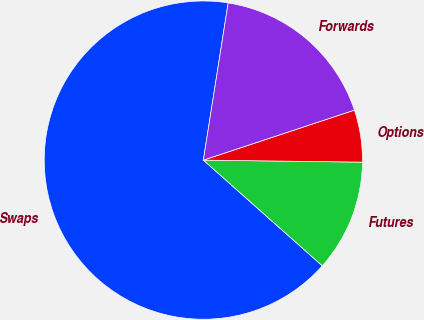Convert chart to OTSL. <chart><loc_0><loc_0><loc_500><loc_500><pie_chart><fcel>Swaps<fcel>Futures<fcel>Options<fcel>Forwards<nl><fcel>65.93%<fcel>11.36%<fcel>5.29%<fcel>17.42%<nl></chart> 